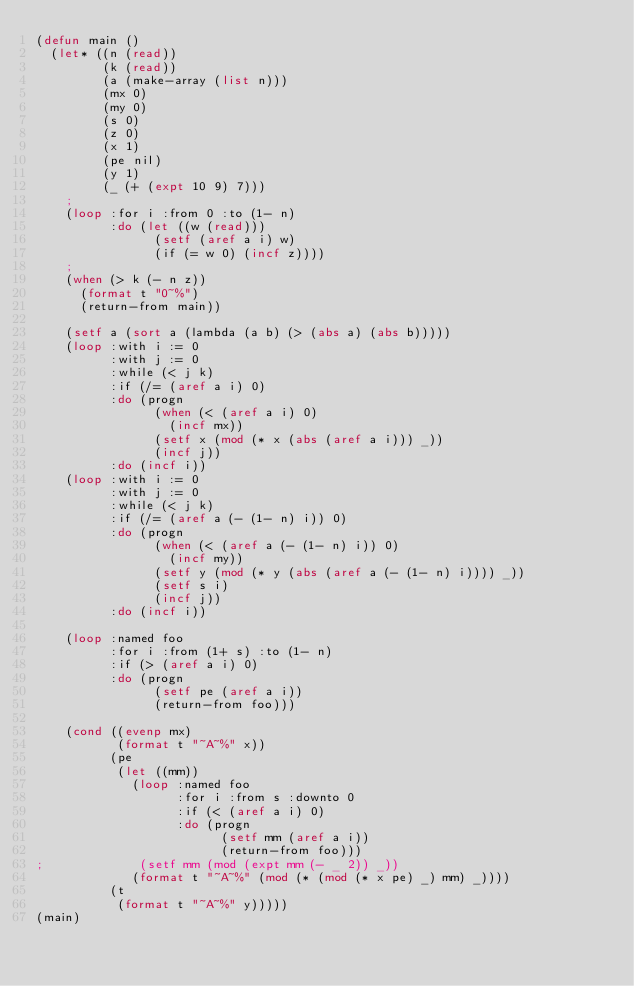Convert code to text. <code><loc_0><loc_0><loc_500><loc_500><_Lisp_>(defun main ()
  (let* ((n (read))
         (k (read))
         (a (make-array (list n)))
         (mx 0)
         (my 0)
         (s 0)
         (z 0)
         (x 1)
         (pe nil)
         (y 1)
         (_ (+ (expt 10 9) 7)))
    ;
    (loop :for i :from 0 :to (1- n)
          :do (let ((w (read)))
                (setf (aref a i) w)
                (if (= w 0) (incf z))))
    ;
    (when (> k (- n z))
      (format t "0~%")
      (return-from main))
    
    (setf a (sort a (lambda (a b) (> (abs a) (abs b)))))
    (loop :with i := 0
          :with j := 0
          :while (< j k)
          :if (/= (aref a i) 0)
          :do (progn
                (when (< (aref a i) 0)
                  (incf mx))
                (setf x (mod (* x (abs (aref a i))) _))
                (incf j))
          :do (incf i))
    (loop :with i := 0
          :with j := 0
          :while (< j k)
          :if (/= (aref a (- (1- n) i)) 0)
          :do (progn
                (when (< (aref a (- (1- n) i)) 0)
                  (incf my))
                (setf y (mod (* y (abs (aref a (- (1- n) i)))) _))
                (setf s i)
                (incf j))
          :do (incf i))
    
    (loop :named foo
          :for i :from (1+ s) :to (1- n)
          :if (> (aref a i) 0)
          :do (progn
                (setf pe (aref a i))
                (return-from foo)))
    
    (cond ((evenp mx)
           (format t "~A~%" x))
          (pe
           (let ((mm))
             (loop :named foo
                   :for i :from s :downto 0
                   :if (< (aref a i) 0)
                   :do (progn
                         (setf mm (aref a i))
                         (return-from foo)))             
;             (setf mm (mod (expt mm (- _ 2)) _))
             (format t "~A~%" (mod (* (mod (* x pe) _) mm) _))))
          (t
           (format t "~A~%" y)))))
(main)
</code> 